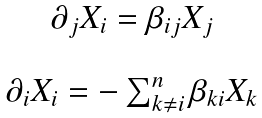Convert formula to latex. <formula><loc_0><loc_0><loc_500><loc_500>\begin{array} { c } \partial _ { j } { X } _ { i } = \beta _ { i j } { X } _ { j } \\ \ \\ \partial _ { i } { X } _ { i } = - \sum _ { k \ne i } ^ { n } \beta _ { k i } { X } _ { k } \end{array}</formula> 